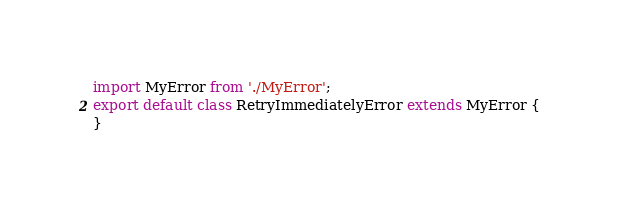<code> <loc_0><loc_0><loc_500><loc_500><_TypeScript_>import MyError from './MyError';
export default class RetryImmediatelyError extends MyError {
}
</code> 